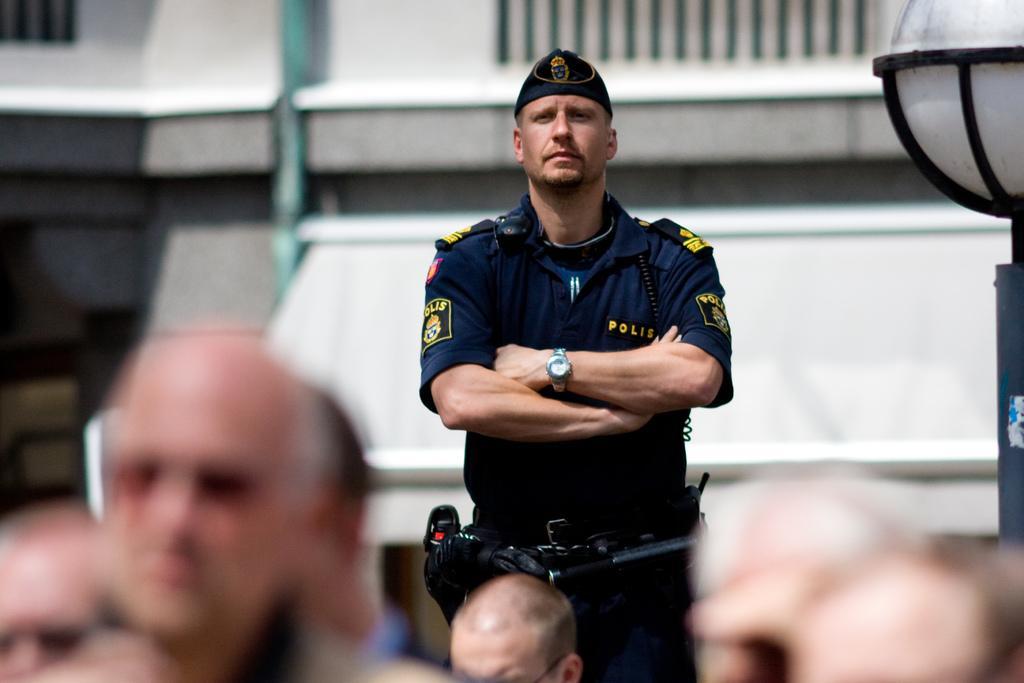Can you describe this image briefly? In this image I can see the person wearing the uniform. In-front of the person I can see the group of people. To the right I can see the pole. In the background I can see the building. 